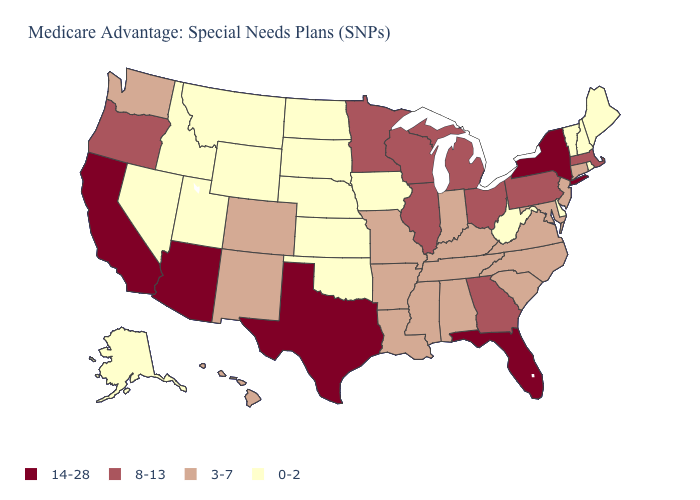Does California have a higher value than Texas?
Keep it brief. No. What is the value of Washington?
Quick response, please. 3-7. What is the value of Illinois?
Write a very short answer. 8-13. What is the value of Oregon?
Concise answer only. 8-13. Does the map have missing data?
Give a very brief answer. No. Which states have the lowest value in the USA?
Be succinct. Alaska, Delaware, Iowa, Idaho, Kansas, Maine, Montana, North Dakota, Nebraska, New Hampshire, Nevada, Oklahoma, Rhode Island, South Dakota, Utah, Vermont, West Virginia, Wyoming. Does the first symbol in the legend represent the smallest category?
Quick response, please. No. What is the lowest value in the South?
Short answer required. 0-2. Name the states that have a value in the range 14-28?
Answer briefly. Arizona, California, Florida, New York, Texas. Name the states that have a value in the range 3-7?
Quick response, please. Alabama, Arkansas, Colorado, Connecticut, Hawaii, Indiana, Kentucky, Louisiana, Maryland, Missouri, Mississippi, North Carolina, New Jersey, New Mexico, South Carolina, Tennessee, Virginia, Washington. What is the value of Tennessee?
Quick response, please. 3-7. What is the value of Idaho?
Concise answer only. 0-2. Name the states that have a value in the range 8-13?
Short answer required. Georgia, Illinois, Massachusetts, Michigan, Minnesota, Ohio, Oregon, Pennsylvania, Wisconsin. What is the value of Alaska?
Be succinct. 0-2. Does Utah have the lowest value in the West?
Keep it brief. Yes. 